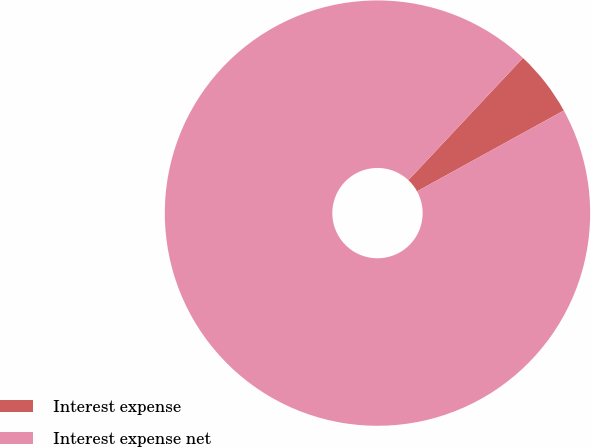Convert chart. <chart><loc_0><loc_0><loc_500><loc_500><pie_chart><fcel>Interest expense<fcel>Interest expense net<nl><fcel>5.0%<fcel>95.0%<nl></chart> 